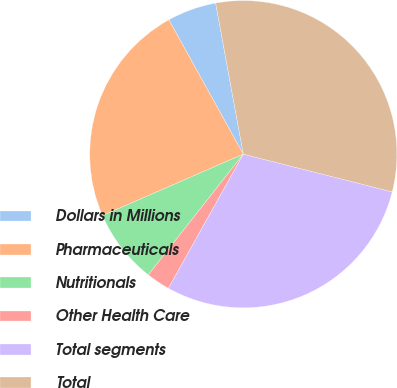<chart> <loc_0><loc_0><loc_500><loc_500><pie_chart><fcel>Dollars in Millions<fcel>Pharmaceuticals<fcel>Nutritionals<fcel>Other Health Care<fcel>Total segments<fcel>Total<nl><fcel>5.17%<fcel>23.49%<fcel>7.84%<fcel>2.51%<fcel>29.16%<fcel>31.83%<nl></chart> 